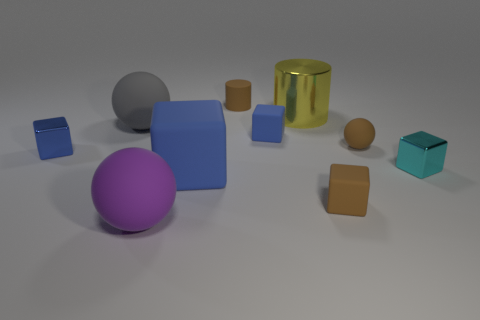How many spheres are the same material as the large gray thing?
Your answer should be very brief. 2. There is a blue shiny object; does it have the same size as the rubber block that is left of the tiny cylinder?
Provide a succinct answer. No. What is the color of the matte object that is both in front of the tiny sphere and to the right of the yellow shiny cylinder?
Give a very brief answer. Brown. There is a cylinder that is right of the tiny brown matte cylinder; is there a blue rubber cube to the right of it?
Offer a very short reply. No. Is the number of blue cubes in front of the cyan shiny object the same as the number of yellow metallic cylinders?
Keep it short and to the point. Yes. What number of small blue metallic blocks are in front of the small brown object on the left side of the large yellow shiny object that is behind the brown matte cube?
Your answer should be very brief. 1. Is there a yellow matte cylinder that has the same size as the purple ball?
Offer a very short reply. No. Is the number of matte objects that are in front of the big purple ball less than the number of blue shiny cylinders?
Your answer should be compact. No. The ball in front of the block that is right of the small brown rubber thing that is in front of the cyan shiny block is made of what material?
Offer a terse response. Rubber. Are there more tiny brown matte cylinders in front of the big blue rubber object than big blue objects that are to the left of the brown cylinder?
Your answer should be compact. No. 